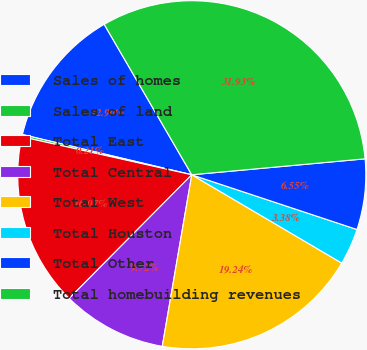<chart> <loc_0><loc_0><loc_500><loc_500><pie_chart><fcel>Sales of homes<fcel>Sales of land<fcel>Total East<fcel>Total Central<fcel>Total West<fcel>Total Houston<fcel>Total Other<fcel>Total homebuilding revenues<nl><fcel>12.9%<fcel>0.21%<fcel>16.07%<fcel>9.72%<fcel>19.24%<fcel>3.38%<fcel>6.55%<fcel>31.93%<nl></chart> 